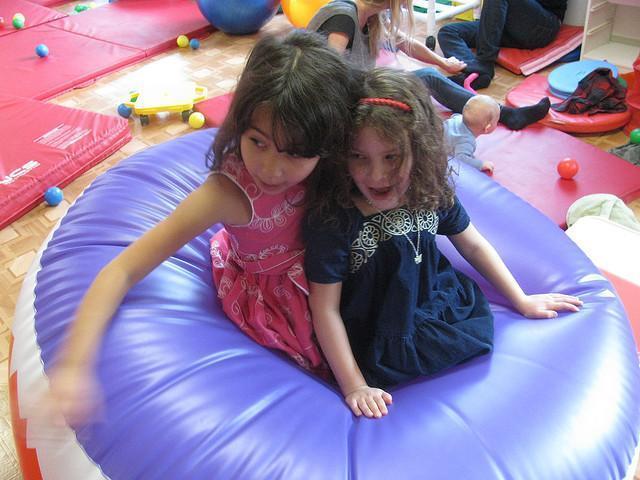How many boys are here?
Give a very brief answer. 0. How many people are there?
Give a very brief answer. 4. How many birds are flying?
Give a very brief answer. 0. 